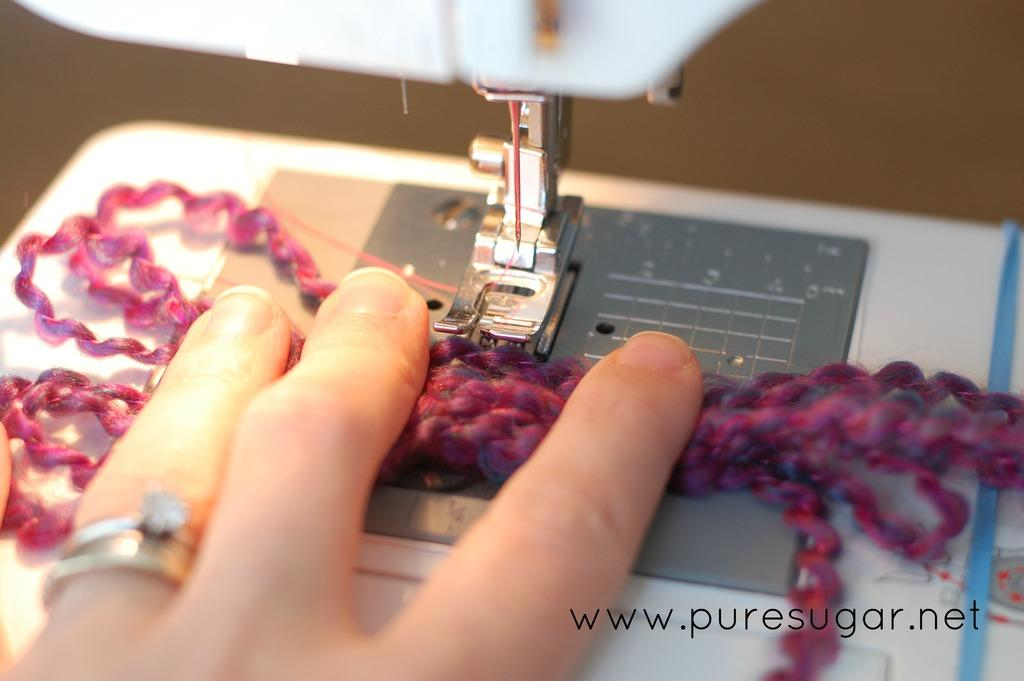What part of a person can be seen in the image? There is a person's hand in the image. What object is present in the image? There is an object in the image, which is a stitching machine. Where is the text located in the image? The text is in the bottom right corner of the image. What type of wall is visible in the image? There is no wall visible in the image. How is the stitching machine being used in the image? The image does not show the stitching machine being used; it only shows the machine itself. 